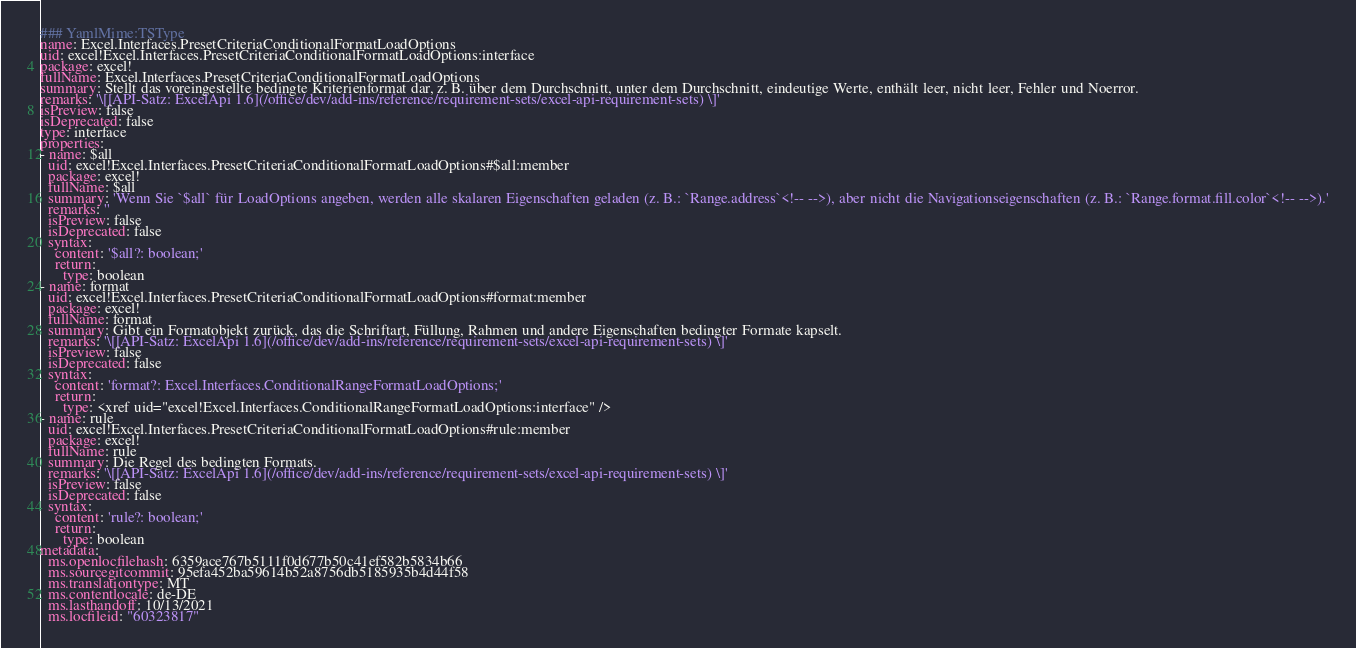<code> <loc_0><loc_0><loc_500><loc_500><_YAML_>### YamlMime:TSType
name: Excel.Interfaces.PresetCriteriaConditionalFormatLoadOptions
uid: excel!Excel.Interfaces.PresetCriteriaConditionalFormatLoadOptions:interface
package: excel!
fullName: Excel.Interfaces.PresetCriteriaConditionalFormatLoadOptions
summary: Stellt das voreingestellte bedingte Kriterienformat dar, z. B. über dem Durchschnitt, unter dem Durchschnitt, eindeutige Werte, enthält leer, nicht leer, Fehler und Noerror.
remarks: '\[[API-Satz: ExcelApi 1.6](/office/dev/add-ins/reference/requirement-sets/excel-api-requirement-sets) \]'
isPreview: false
isDeprecated: false
type: interface
properties:
- name: $all
  uid: excel!Excel.Interfaces.PresetCriteriaConditionalFormatLoadOptions#$all:member
  package: excel!
  fullName: $all
  summary: 'Wenn Sie `$all` für LoadOptions angeben, werden alle skalaren Eigenschaften geladen (z. B.: `Range.address`<!-- -->), aber nicht die Navigationseigenschaften (z. B.: `Range.format.fill.color`<!-- -->).'
  remarks: ''
  isPreview: false
  isDeprecated: false
  syntax:
    content: '$all?: boolean;'
    return:
      type: boolean
- name: format
  uid: excel!Excel.Interfaces.PresetCriteriaConditionalFormatLoadOptions#format:member
  package: excel!
  fullName: format
  summary: Gibt ein Formatobjekt zurück, das die Schriftart, Füllung, Rahmen und andere Eigenschaften bedingter Formate kapselt.
  remarks: '\[[API-Satz: ExcelApi 1.6](/office/dev/add-ins/reference/requirement-sets/excel-api-requirement-sets) \]'
  isPreview: false
  isDeprecated: false
  syntax:
    content: 'format?: Excel.Interfaces.ConditionalRangeFormatLoadOptions;'
    return:
      type: <xref uid="excel!Excel.Interfaces.ConditionalRangeFormatLoadOptions:interface" />
- name: rule
  uid: excel!Excel.Interfaces.PresetCriteriaConditionalFormatLoadOptions#rule:member
  package: excel!
  fullName: rule
  summary: Die Regel des bedingten Formats.
  remarks: '\[[API-Satz: ExcelApi 1.6](/office/dev/add-ins/reference/requirement-sets/excel-api-requirement-sets) \]'
  isPreview: false
  isDeprecated: false
  syntax:
    content: 'rule?: boolean;'
    return:
      type: boolean
metadata:
  ms.openlocfilehash: 6359ace767b5111f0d677b50c41ef582b5834b66
  ms.sourcegitcommit: 95efa452ba59614b52a8756db5185935b4d44f58
  ms.translationtype: MT
  ms.contentlocale: de-DE
  ms.lasthandoff: 10/13/2021
  ms.locfileid: "60323817"
</code> 